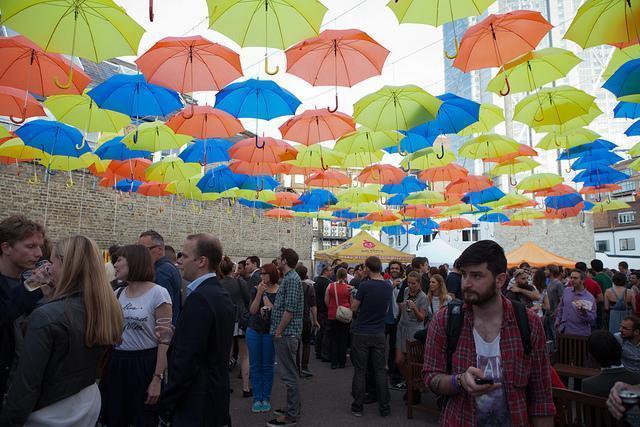How many umbrellas can be seen?
Give a very brief answer. 10. How many people are visible?
Give a very brief answer. 9. 